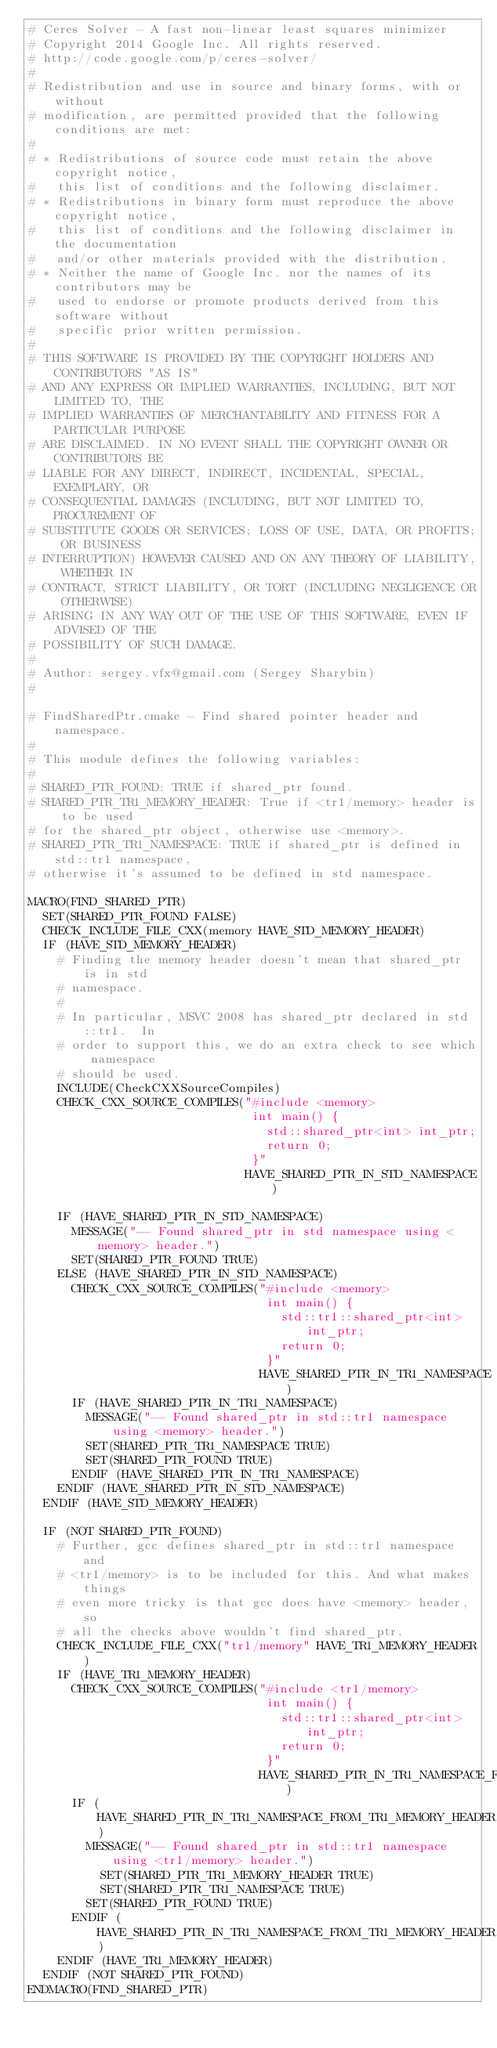<code> <loc_0><loc_0><loc_500><loc_500><_CMake_># Ceres Solver - A fast non-linear least squares minimizer
# Copyright 2014 Google Inc. All rights reserved.
# http://code.google.com/p/ceres-solver/
#
# Redistribution and use in source and binary forms, with or without
# modification, are permitted provided that the following conditions are met:
#
# * Redistributions of source code must retain the above copyright notice,
#   this list of conditions and the following disclaimer.
# * Redistributions in binary form must reproduce the above copyright notice,
#   this list of conditions and the following disclaimer in the documentation
#   and/or other materials provided with the distribution.
# * Neither the name of Google Inc. nor the names of its contributors may be
#   used to endorse or promote products derived from this software without
#   specific prior written permission.
#
# THIS SOFTWARE IS PROVIDED BY THE COPYRIGHT HOLDERS AND CONTRIBUTORS "AS IS"
# AND ANY EXPRESS OR IMPLIED WARRANTIES, INCLUDING, BUT NOT LIMITED TO, THE
# IMPLIED WARRANTIES OF MERCHANTABILITY AND FITNESS FOR A PARTICULAR PURPOSE
# ARE DISCLAIMED. IN NO EVENT SHALL THE COPYRIGHT OWNER OR CONTRIBUTORS BE
# LIABLE FOR ANY DIRECT, INDIRECT, INCIDENTAL, SPECIAL, EXEMPLARY, OR
# CONSEQUENTIAL DAMAGES (INCLUDING, BUT NOT LIMITED TO, PROCUREMENT OF
# SUBSTITUTE GOODS OR SERVICES; LOSS OF USE, DATA, OR PROFITS; OR BUSINESS
# INTERRUPTION) HOWEVER CAUSED AND ON ANY THEORY OF LIABILITY, WHETHER IN
# CONTRACT, STRICT LIABILITY, OR TORT (INCLUDING NEGLIGENCE OR OTHERWISE)
# ARISING IN ANY WAY OUT OF THE USE OF THIS SOFTWARE, EVEN IF ADVISED OF THE
# POSSIBILITY OF SUCH DAMAGE.
#
# Author: sergey.vfx@gmail.com (Sergey Sharybin)
#

# FindSharedPtr.cmake - Find shared pointer header and namespace.
#
# This module defines the following variables:
#
# SHARED_PTR_FOUND: TRUE if shared_ptr found.
# SHARED_PTR_TR1_MEMORY_HEADER: True if <tr1/memory> header is to be used
# for the shared_ptr object, otherwise use <memory>.
# SHARED_PTR_TR1_NAMESPACE: TRUE if shared_ptr is defined in std::tr1 namespace,
# otherwise it's assumed to be defined in std namespace.

MACRO(FIND_SHARED_PTR)
  SET(SHARED_PTR_FOUND FALSE)
  CHECK_INCLUDE_FILE_CXX(memory HAVE_STD_MEMORY_HEADER)
  IF (HAVE_STD_MEMORY_HEADER)
    # Finding the memory header doesn't mean that shared_ptr is in std
    # namespace.
    #
    # In particular, MSVC 2008 has shared_ptr declared in std::tr1.  In
    # order to support this, we do an extra check to see which namespace
    # should be used.
    INCLUDE(CheckCXXSourceCompiles)
    CHECK_CXX_SOURCE_COMPILES("#include <memory>
                               int main() {
                                 std::shared_ptr<int> int_ptr;
                                 return 0;
                               }"
                              HAVE_SHARED_PTR_IN_STD_NAMESPACE)

    IF (HAVE_SHARED_PTR_IN_STD_NAMESPACE)
      MESSAGE("-- Found shared_ptr in std namespace using <memory> header.")
      SET(SHARED_PTR_FOUND TRUE)
    ELSE (HAVE_SHARED_PTR_IN_STD_NAMESPACE)
      CHECK_CXX_SOURCE_COMPILES("#include <memory>
                                 int main() {
                                   std::tr1::shared_ptr<int> int_ptr;
                                   return 0;
                                 }"
                                HAVE_SHARED_PTR_IN_TR1_NAMESPACE)
      IF (HAVE_SHARED_PTR_IN_TR1_NAMESPACE)
        MESSAGE("-- Found shared_ptr in std::tr1 namespace using <memory> header.")
        SET(SHARED_PTR_TR1_NAMESPACE TRUE)
        SET(SHARED_PTR_FOUND TRUE)
      ENDIF (HAVE_SHARED_PTR_IN_TR1_NAMESPACE)
    ENDIF (HAVE_SHARED_PTR_IN_STD_NAMESPACE)
  ENDIF (HAVE_STD_MEMORY_HEADER)

  IF (NOT SHARED_PTR_FOUND)
    # Further, gcc defines shared_ptr in std::tr1 namespace and
    # <tr1/memory> is to be included for this. And what makes things
    # even more tricky is that gcc does have <memory> header, so
    # all the checks above wouldn't find shared_ptr.
    CHECK_INCLUDE_FILE_CXX("tr1/memory" HAVE_TR1_MEMORY_HEADER)
    IF (HAVE_TR1_MEMORY_HEADER)
      CHECK_CXX_SOURCE_COMPILES("#include <tr1/memory>
                                 int main() {
                                   std::tr1::shared_ptr<int> int_ptr;
                                   return 0;
                                 }"
                                HAVE_SHARED_PTR_IN_TR1_NAMESPACE_FROM_TR1_MEMORY_HEADER)
      IF (HAVE_SHARED_PTR_IN_TR1_NAMESPACE_FROM_TR1_MEMORY_HEADER)
        MESSAGE("-- Found shared_ptr in std::tr1 namespace using <tr1/memory> header.")
          SET(SHARED_PTR_TR1_MEMORY_HEADER TRUE)
          SET(SHARED_PTR_TR1_NAMESPACE TRUE)
        SET(SHARED_PTR_FOUND TRUE)
      ENDIF (HAVE_SHARED_PTR_IN_TR1_NAMESPACE_FROM_TR1_MEMORY_HEADER)
    ENDIF (HAVE_TR1_MEMORY_HEADER)
  ENDIF (NOT SHARED_PTR_FOUND)
ENDMACRO(FIND_SHARED_PTR)
</code> 